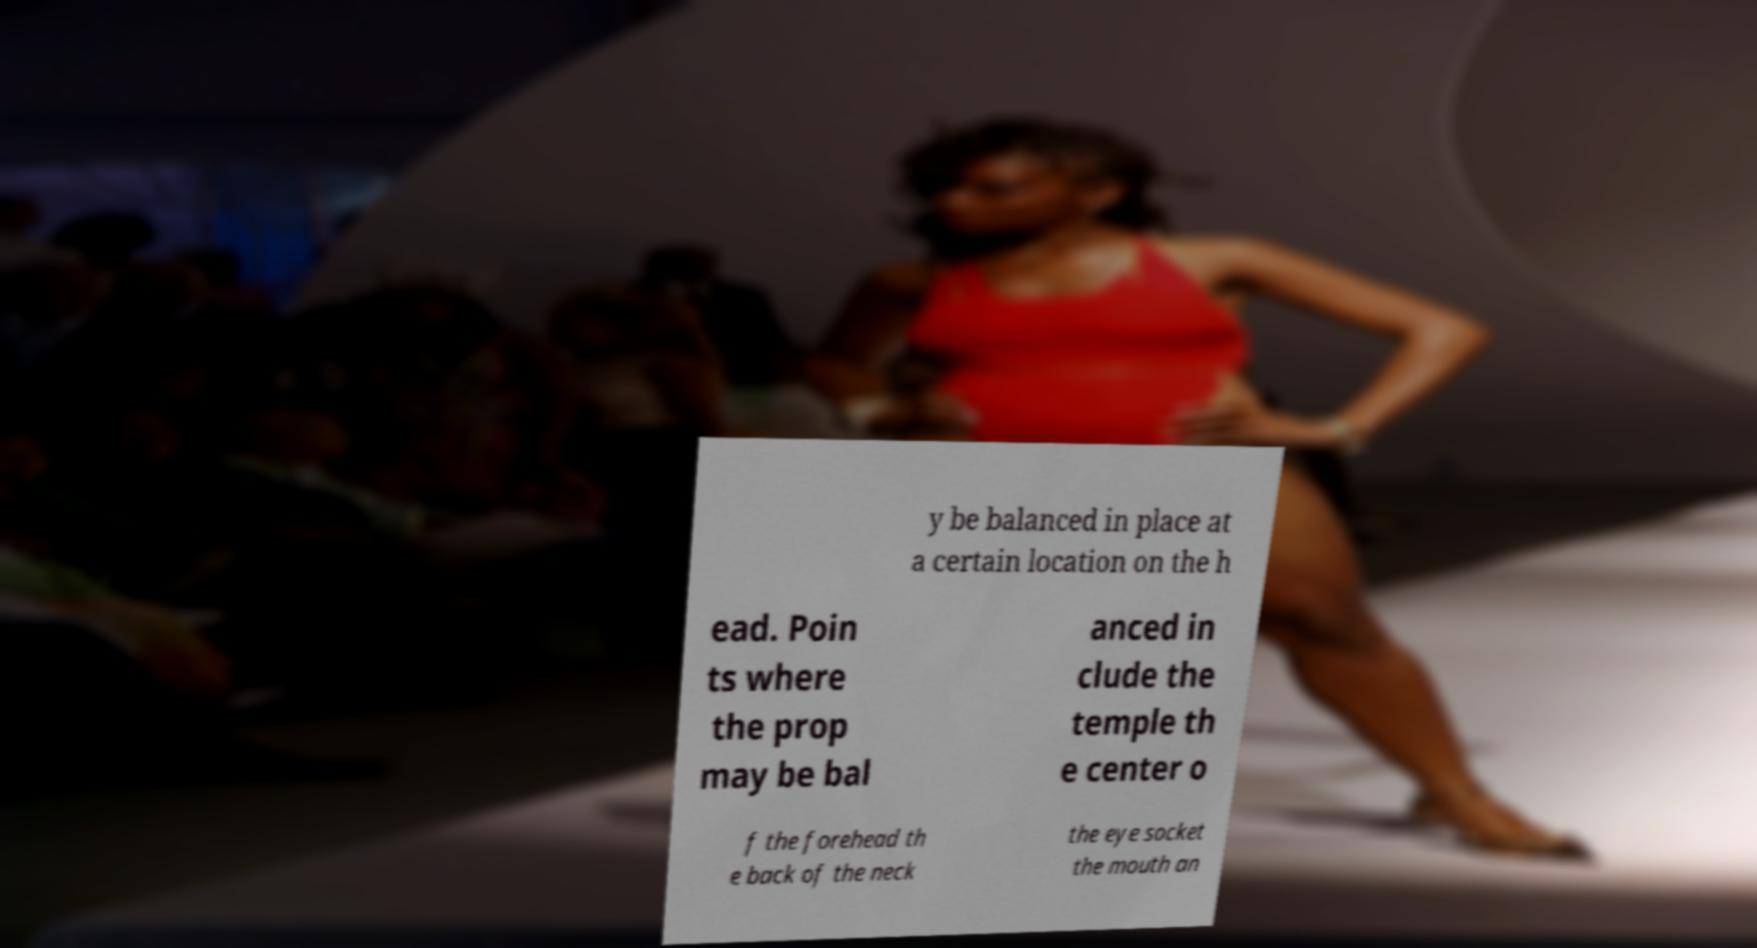Can you read and provide the text displayed in the image?This photo seems to have some interesting text. Can you extract and type it out for me? y be balanced in place at a certain location on the h ead. Poin ts where the prop may be bal anced in clude the temple th e center o f the forehead th e back of the neck the eye socket the mouth an 